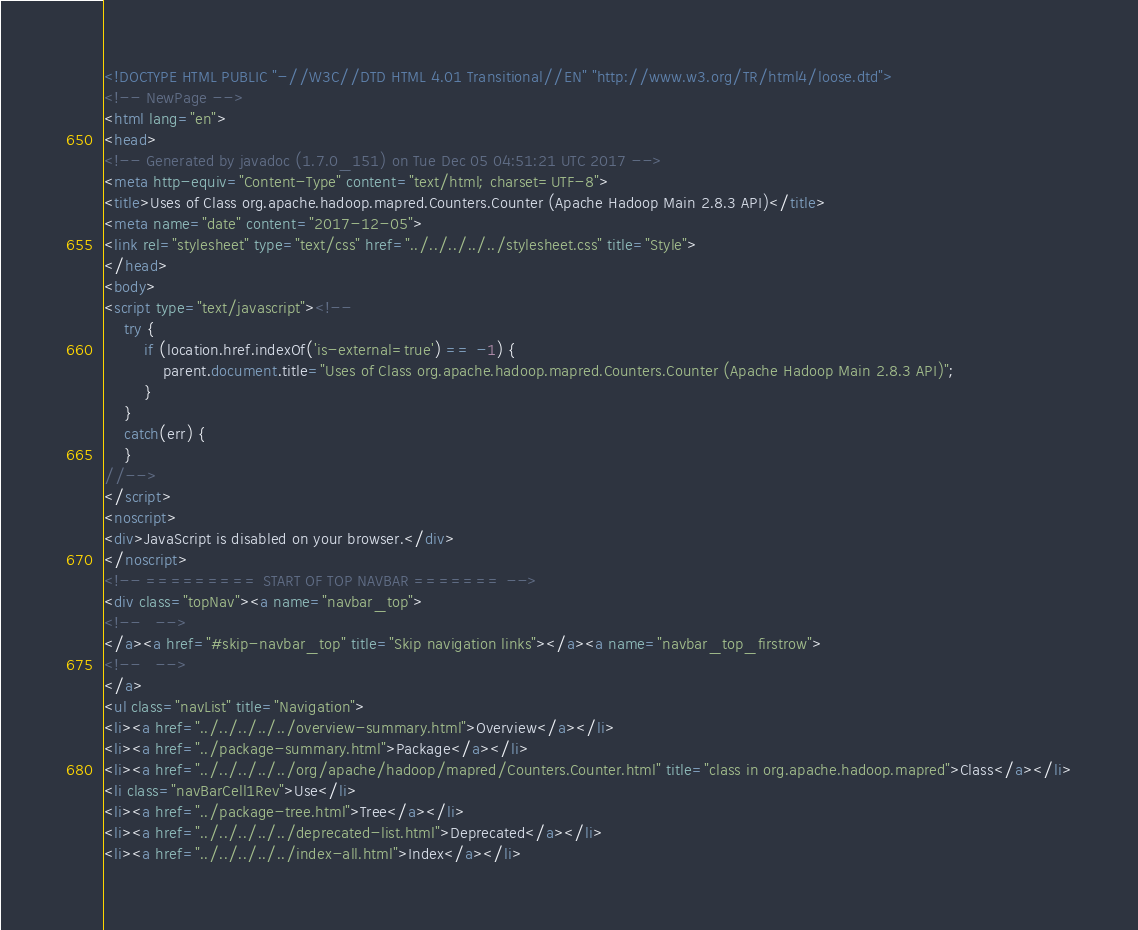<code> <loc_0><loc_0><loc_500><loc_500><_HTML_><!DOCTYPE HTML PUBLIC "-//W3C//DTD HTML 4.01 Transitional//EN" "http://www.w3.org/TR/html4/loose.dtd">
<!-- NewPage -->
<html lang="en">
<head>
<!-- Generated by javadoc (1.7.0_151) on Tue Dec 05 04:51:21 UTC 2017 -->
<meta http-equiv="Content-Type" content="text/html; charset=UTF-8">
<title>Uses of Class org.apache.hadoop.mapred.Counters.Counter (Apache Hadoop Main 2.8.3 API)</title>
<meta name="date" content="2017-12-05">
<link rel="stylesheet" type="text/css" href="../../../../../stylesheet.css" title="Style">
</head>
<body>
<script type="text/javascript"><!--
    try {
        if (location.href.indexOf('is-external=true') == -1) {
            parent.document.title="Uses of Class org.apache.hadoop.mapred.Counters.Counter (Apache Hadoop Main 2.8.3 API)";
        }
    }
    catch(err) {
    }
//-->
</script>
<noscript>
<div>JavaScript is disabled on your browser.</div>
</noscript>
<!-- ========= START OF TOP NAVBAR ======= -->
<div class="topNav"><a name="navbar_top">
<!--   -->
</a><a href="#skip-navbar_top" title="Skip navigation links"></a><a name="navbar_top_firstrow">
<!--   -->
</a>
<ul class="navList" title="Navigation">
<li><a href="../../../../../overview-summary.html">Overview</a></li>
<li><a href="../package-summary.html">Package</a></li>
<li><a href="../../../../../org/apache/hadoop/mapred/Counters.Counter.html" title="class in org.apache.hadoop.mapred">Class</a></li>
<li class="navBarCell1Rev">Use</li>
<li><a href="../package-tree.html">Tree</a></li>
<li><a href="../../../../../deprecated-list.html">Deprecated</a></li>
<li><a href="../../../../../index-all.html">Index</a></li></code> 